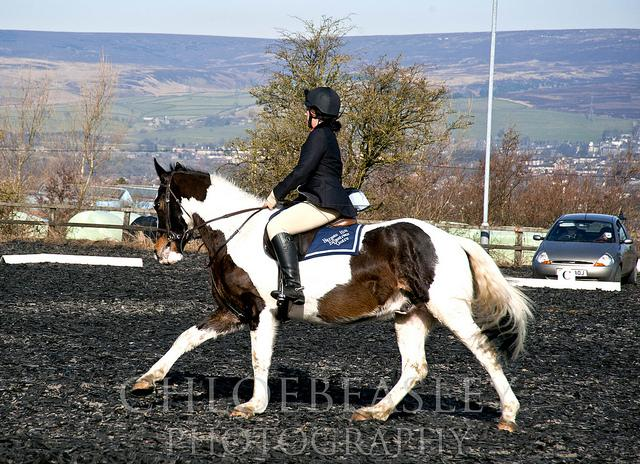What is on top of the horse?

Choices:
A) old man
B) cat
C) girl
D) bird girl 